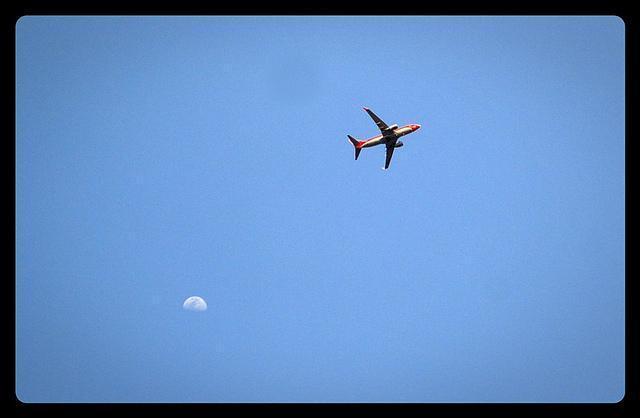How many items does the man hold?
Give a very brief answer. 0. 